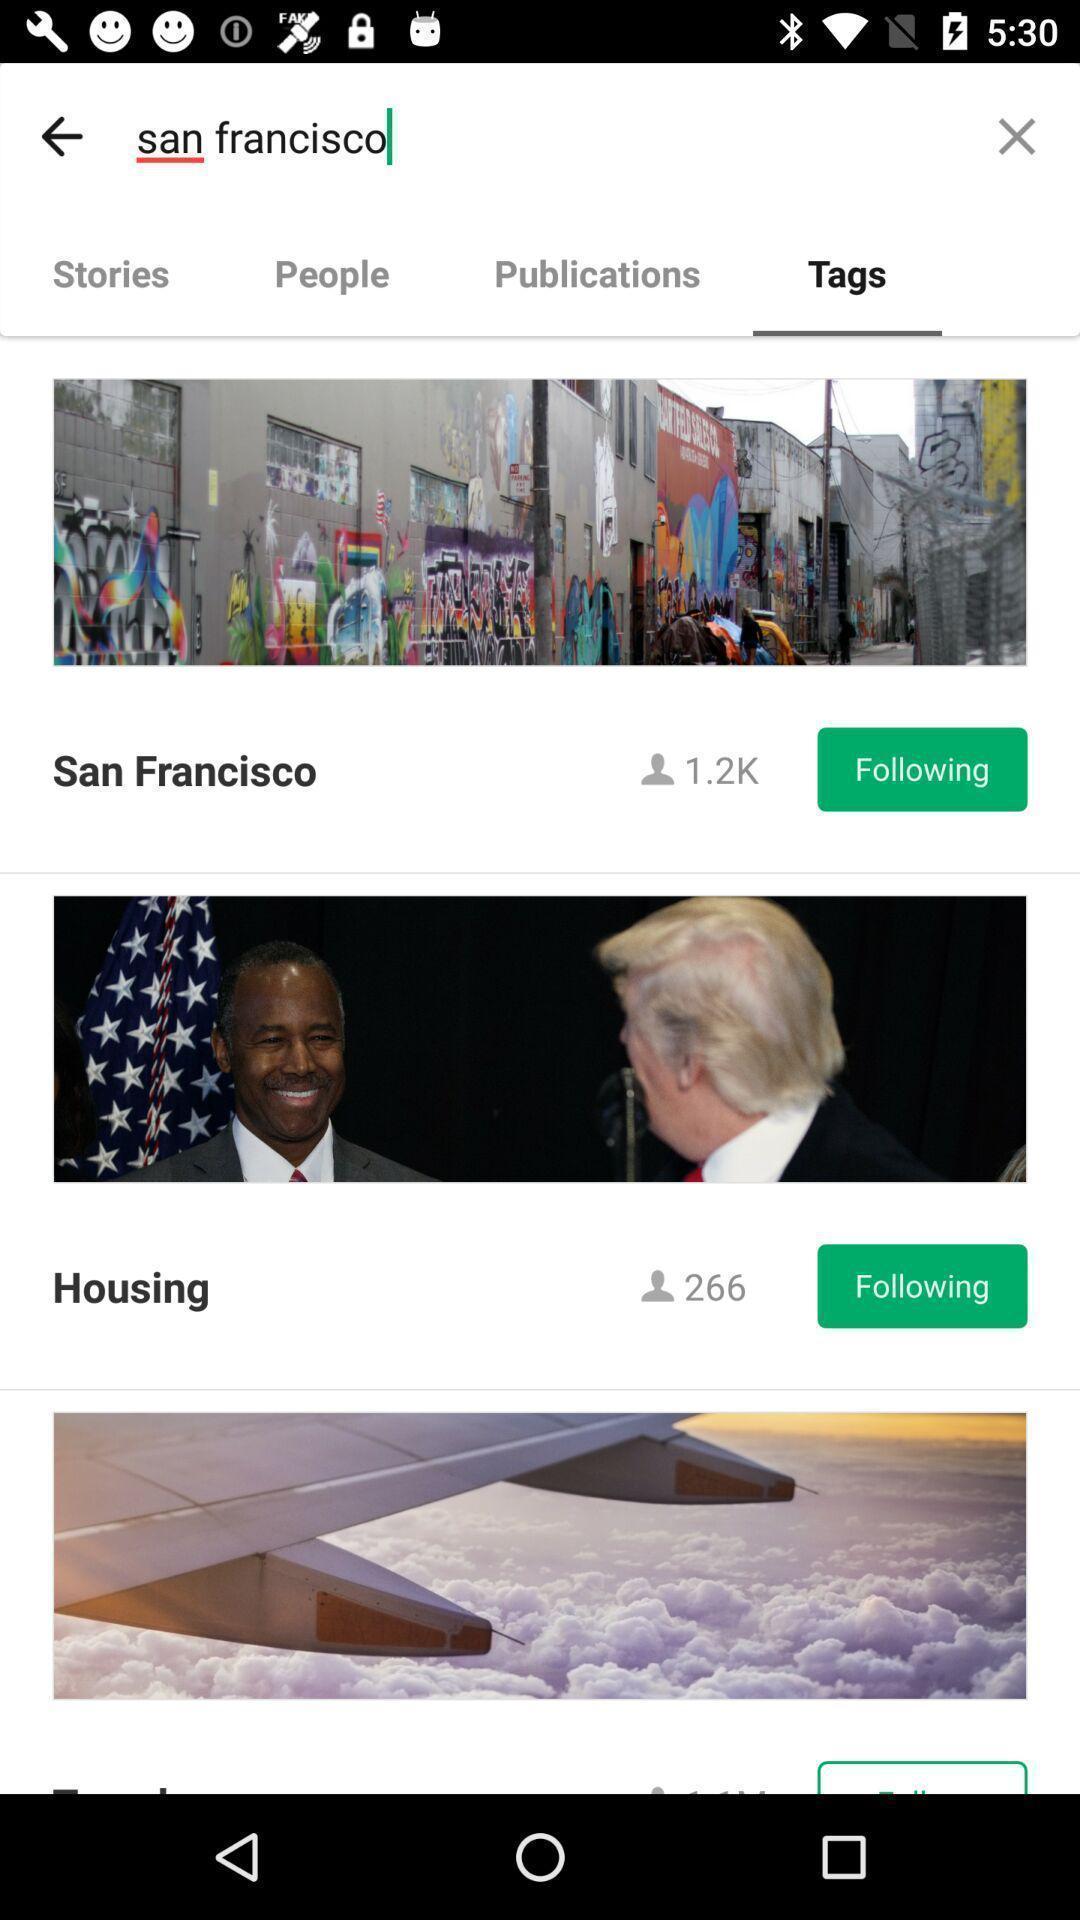Explain the elements present in this screenshot. Screen shows tags in an ad-free digital publisher. 